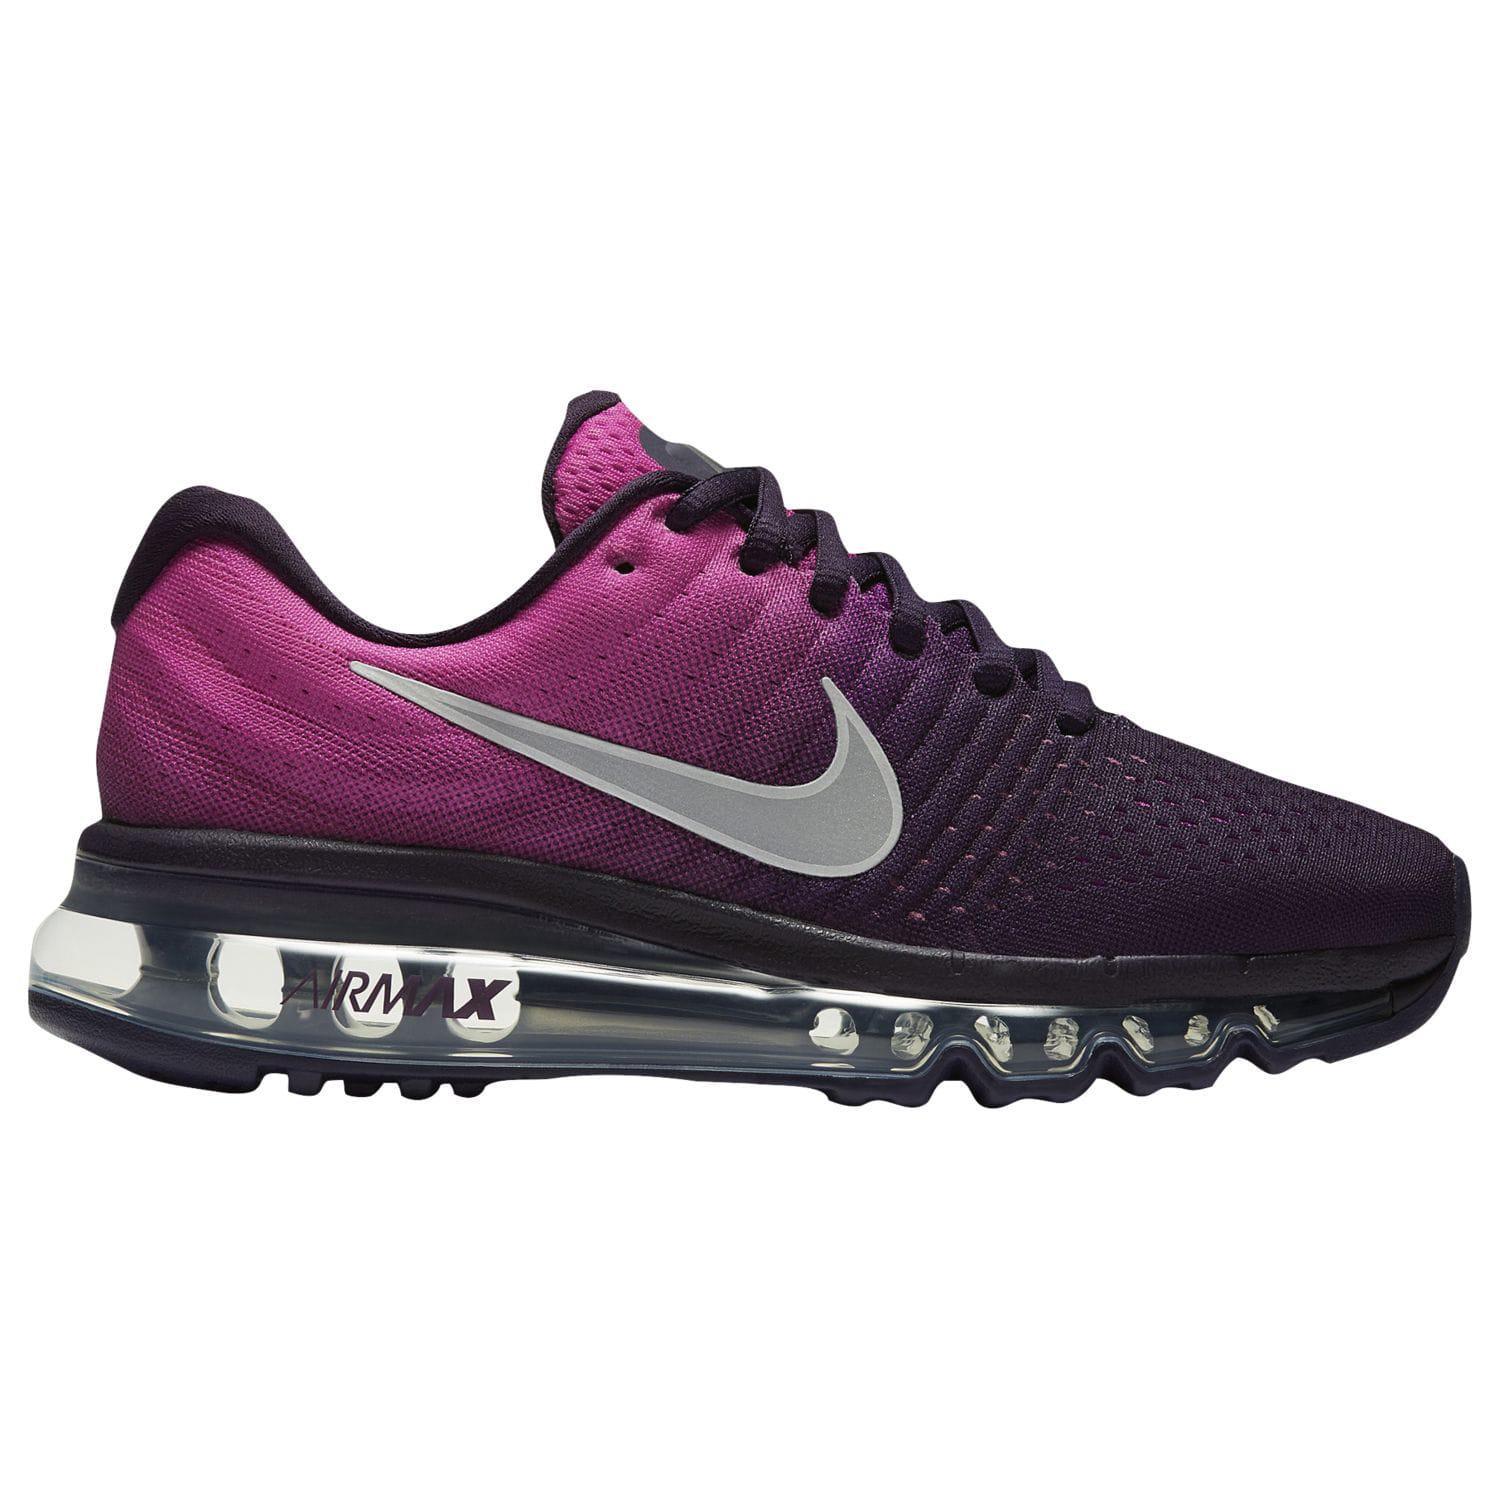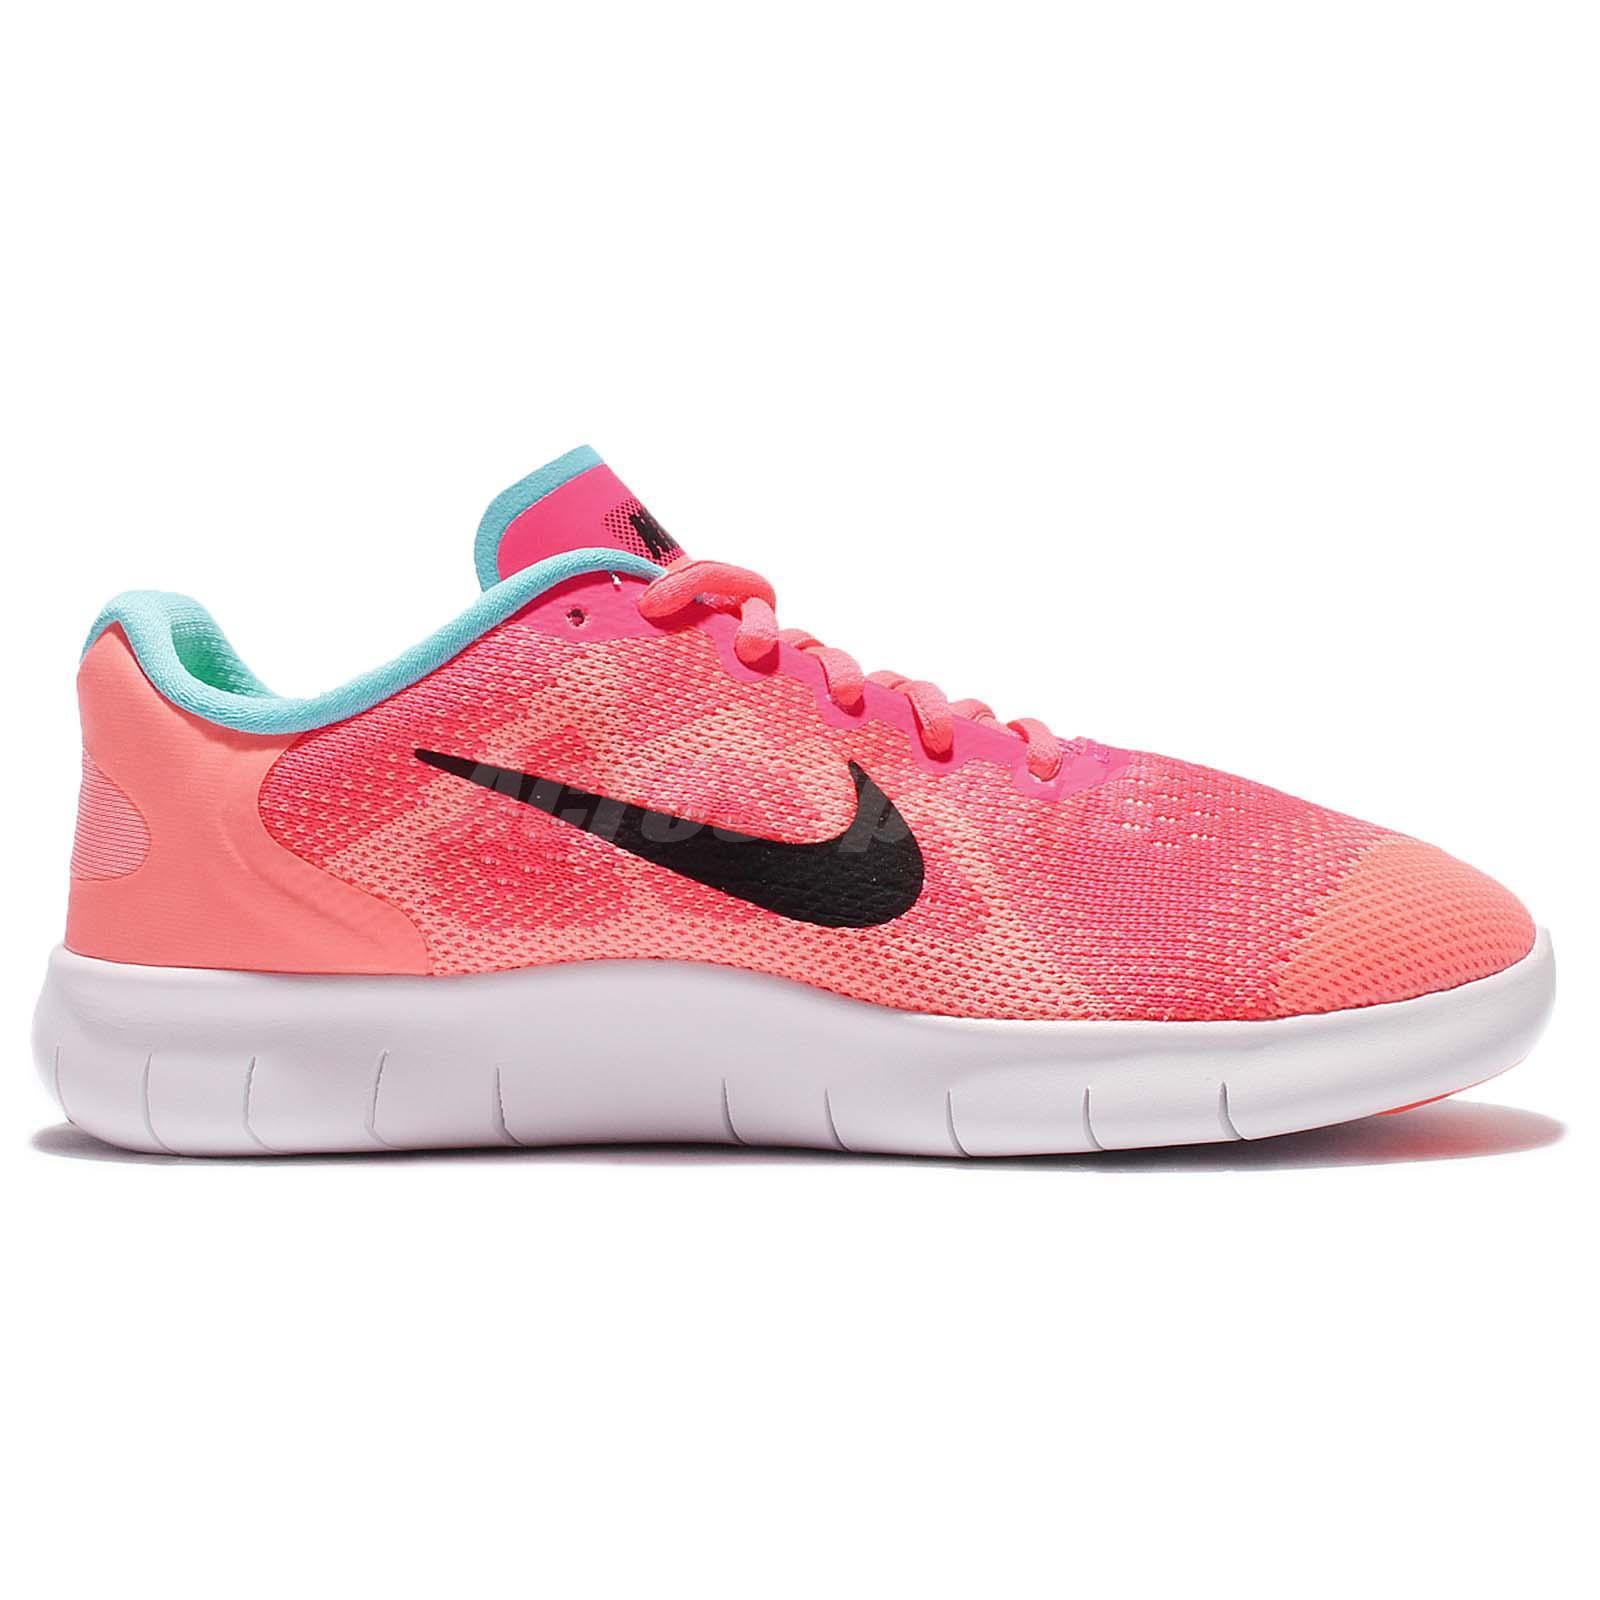The first image is the image on the left, the second image is the image on the right. Evaluate the accuracy of this statement regarding the images: "A single shoe is shown in profile in each of the images.". Is it true? Answer yes or no. Yes. The first image is the image on the left, the second image is the image on the right. For the images shown, is this caption "Each image contains a single sneaker, and exactly one sneaker has pink laces." true? Answer yes or no. Yes. 